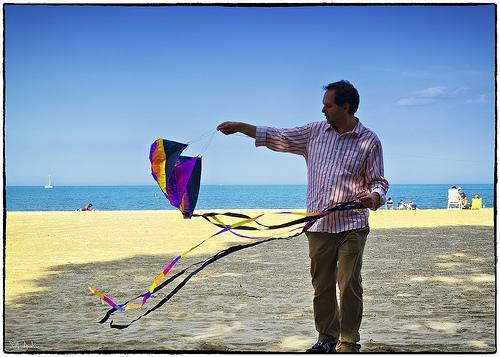How many people are shown?
Give a very brief answer. 1. 